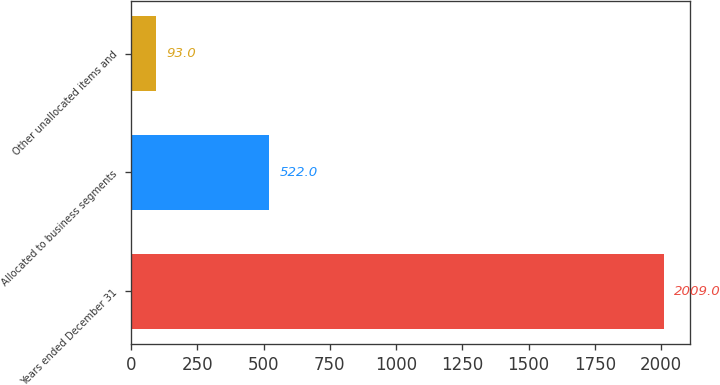Convert chart to OTSL. <chart><loc_0><loc_0><loc_500><loc_500><bar_chart><fcel>Years ended December 31<fcel>Allocated to business segments<fcel>Other unallocated items and<nl><fcel>2009<fcel>522<fcel>93<nl></chart> 